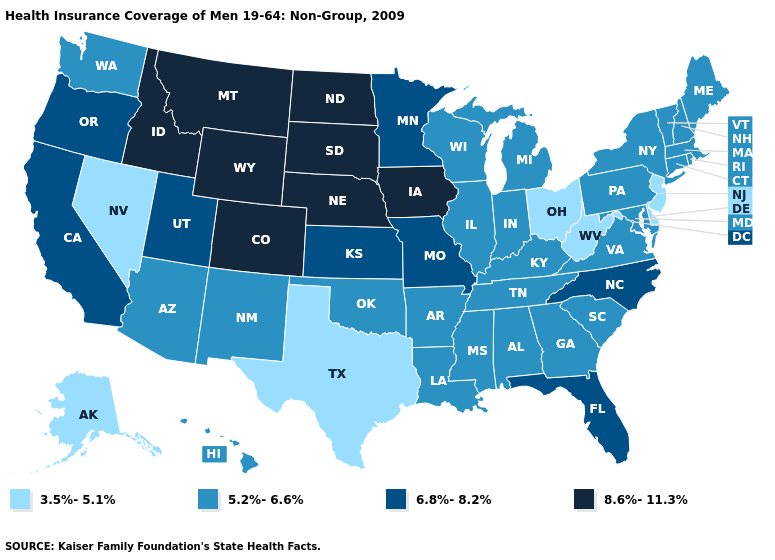Which states have the highest value in the USA?
Give a very brief answer. Colorado, Idaho, Iowa, Montana, Nebraska, North Dakota, South Dakota, Wyoming. Name the states that have a value in the range 3.5%-5.1%?
Quick response, please. Alaska, Delaware, Nevada, New Jersey, Ohio, Texas, West Virginia. Name the states that have a value in the range 5.2%-6.6%?
Keep it brief. Alabama, Arizona, Arkansas, Connecticut, Georgia, Hawaii, Illinois, Indiana, Kentucky, Louisiana, Maine, Maryland, Massachusetts, Michigan, Mississippi, New Hampshire, New Mexico, New York, Oklahoma, Pennsylvania, Rhode Island, South Carolina, Tennessee, Vermont, Virginia, Washington, Wisconsin. What is the value of Tennessee?
Write a very short answer. 5.2%-6.6%. Name the states that have a value in the range 8.6%-11.3%?
Quick response, please. Colorado, Idaho, Iowa, Montana, Nebraska, North Dakota, South Dakota, Wyoming. How many symbols are there in the legend?
Concise answer only. 4. Which states have the lowest value in the USA?
Write a very short answer. Alaska, Delaware, Nevada, New Jersey, Ohio, Texas, West Virginia. Among the states that border Oregon , which have the highest value?
Quick response, please. Idaho. What is the value of Oregon?
Write a very short answer. 6.8%-8.2%. Name the states that have a value in the range 5.2%-6.6%?
Answer briefly. Alabama, Arizona, Arkansas, Connecticut, Georgia, Hawaii, Illinois, Indiana, Kentucky, Louisiana, Maine, Maryland, Massachusetts, Michigan, Mississippi, New Hampshire, New Mexico, New York, Oklahoma, Pennsylvania, Rhode Island, South Carolina, Tennessee, Vermont, Virginia, Washington, Wisconsin. Name the states that have a value in the range 5.2%-6.6%?
Answer briefly. Alabama, Arizona, Arkansas, Connecticut, Georgia, Hawaii, Illinois, Indiana, Kentucky, Louisiana, Maine, Maryland, Massachusetts, Michigan, Mississippi, New Hampshire, New Mexico, New York, Oklahoma, Pennsylvania, Rhode Island, South Carolina, Tennessee, Vermont, Virginia, Washington, Wisconsin. Does Alabama have the highest value in the USA?
Give a very brief answer. No. Does New Jersey have the lowest value in the Northeast?
Be succinct. Yes. Does North Carolina have the lowest value in the USA?
Give a very brief answer. No. Among the states that border Nebraska , does Wyoming have the lowest value?
Concise answer only. No. 